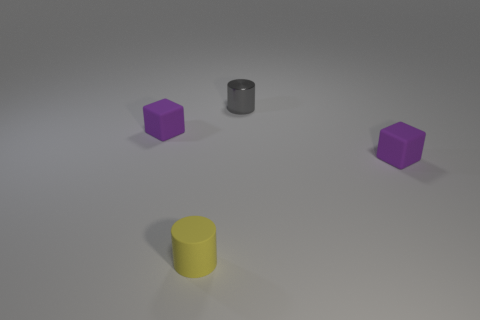Add 4 matte blocks. How many objects exist? 8 Subtract all small cylinders. Subtract all big gray shiny cylinders. How many objects are left? 2 Add 2 small gray shiny things. How many small gray shiny things are left? 3 Add 1 purple rubber cubes. How many purple rubber cubes exist? 3 Subtract 0 brown cylinders. How many objects are left? 4 